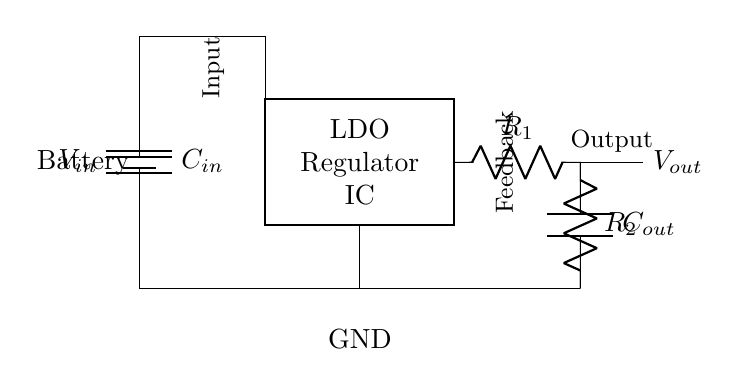What is the input voltage of this circuit? The input voltage is represented by \(V_{in}\), which is the voltage supplied by the battery in the circuit.
Answer: \(V_{in}\) What are the components connected to the ground? The components connected to the ground are the negative terminal of the battery, the bottom terminal of \(C_{out}\), and the output of the regulator showing a connection to the ground line.
Answer: Battery, C out What is the function of the LDO regulator? The LDO (Low-Dropout) regulator's function is to provide a stable output voltage (\(V_{out}\)) from the input voltage (\(V_{in}\)), ensuring efficient power conversion with minimal voltage drop.
Answer: Voltage regulation What is the role of \(C_{in}\)? \(C_{in}\) is the input capacitor, and its role is to filter the input voltage to the LDO, providing a stable power supply and reducing voltage fluctuations when the circuit is powered.
Answer: Filter input voltage How many feedback resistors are there in the circuit? There are two feedback resistors labeled \(R_1\) and \(R_2\), which create a voltage divider to set the output voltage of the LDO.
Answer: Two What would happen if \(C_{out}\) is removed? If \(C_{out}\) is removed, the circuit may experience output voltage instability and increased ripple, compromising the performance of the portable electronic device, as the LDO relies on the capacitor for smoothing.
Answer: Instability What is the purpose of the feedback resistors \(R_1\) and \(R_2\)? The feedback resistors create a voltage divider that feeds back a portion of the output voltage to the LDO, allowing it to adjust its output and maintain a constant voltage level at \(V_{out}\).
Answer: Voltage adjustment 